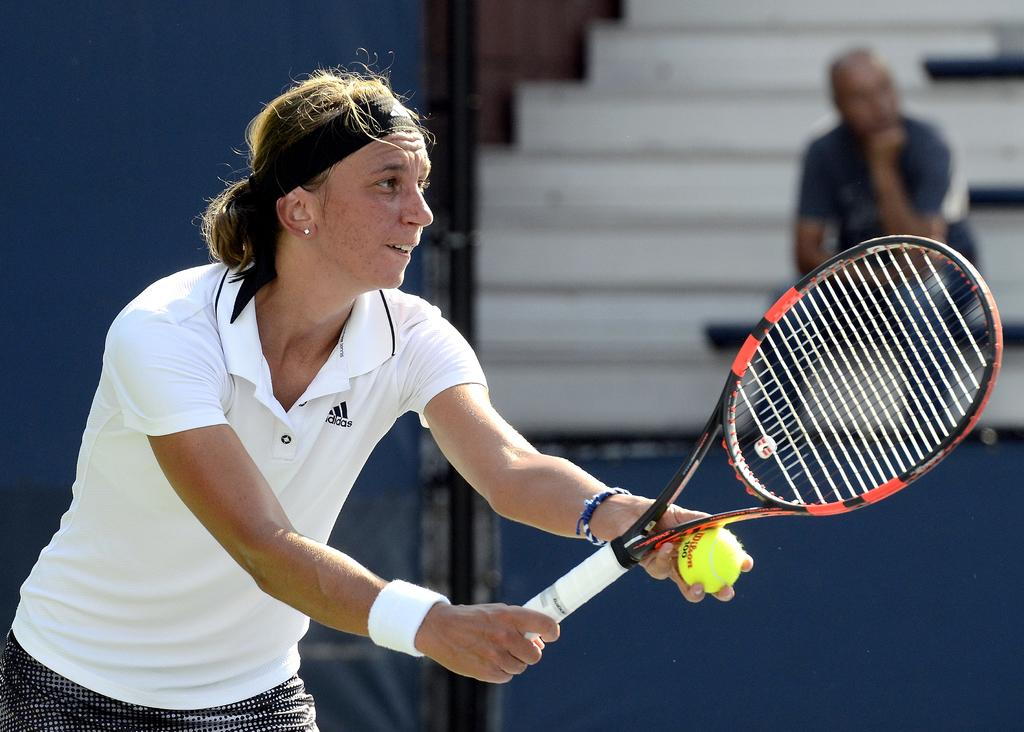What is the person in the image holding? The person is holding a tennis racket and a tennis ball. What might the person be doing with the tennis racket and ball? The person might be playing tennis or preparing to play. Can you describe the other person in the image? There is another person sitting in the background of the image. What type of print can be seen on the tennis racket in the image? There is no specific print visible on the tennis racket in the image. How does the beginner tennis player turn around in the image? There is no indication that the person holding the tennis racket is a beginner, nor is there any movement or turning visible in the image. 